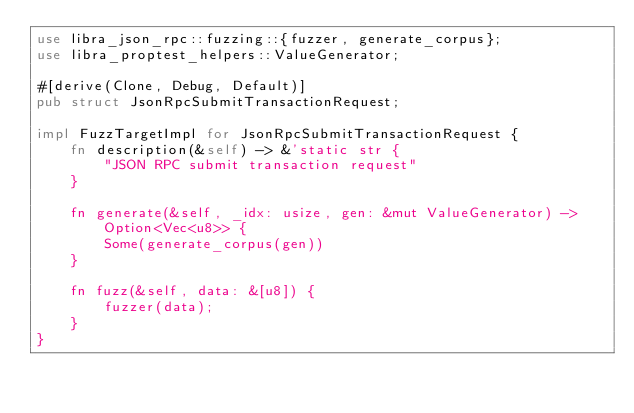<code> <loc_0><loc_0><loc_500><loc_500><_Rust_>use libra_json_rpc::fuzzing::{fuzzer, generate_corpus};
use libra_proptest_helpers::ValueGenerator;

#[derive(Clone, Debug, Default)]
pub struct JsonRpcSubmitTransactionRequest;

impl FuzzTargetImpl for JsonRpcSubmitTransactionRequest {
    fn description(&self) -> &'static str {
        "JSON RPC submit transaction request"
    }

    fn generate(&self, _idx: usize, gen: &mut ValueGenerator) -> Option<Vec<u8>> {
        Some(generate_corpus(gen))
    }

    fn fuzz(&self, data: &[u8]) {
        fuzzer(data);
    }
}
</code> 